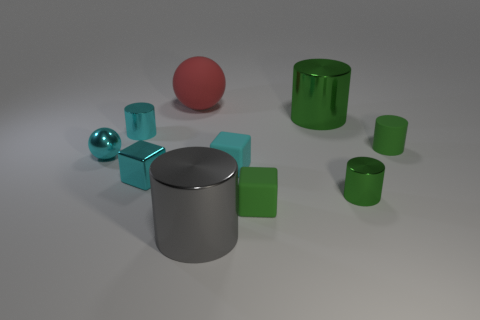Subtract all small green matte cylinders. How many cylinders are left? 4 Subtract all cyan spheres. How many spheres are left? 1 Subtract all cyan blocks. Subtract all red balls. How many blocks are left? 1 Subtract all yellow spheres. How many green blocks are left? 1 Subtract all small cyan matte objects. Subtract all big green objects. How many objects are left? 8 Add 6 small green cylinders. How many small green cylinders are left? 8 Add 4 big brown things. How many big brown things exist? 4 Subtract 0 purple cubes. How many objects are left? 10 Subtract all cubes. How many objects are left? 7 Subtract 2 cylinders. How many cylinders are left? 3 